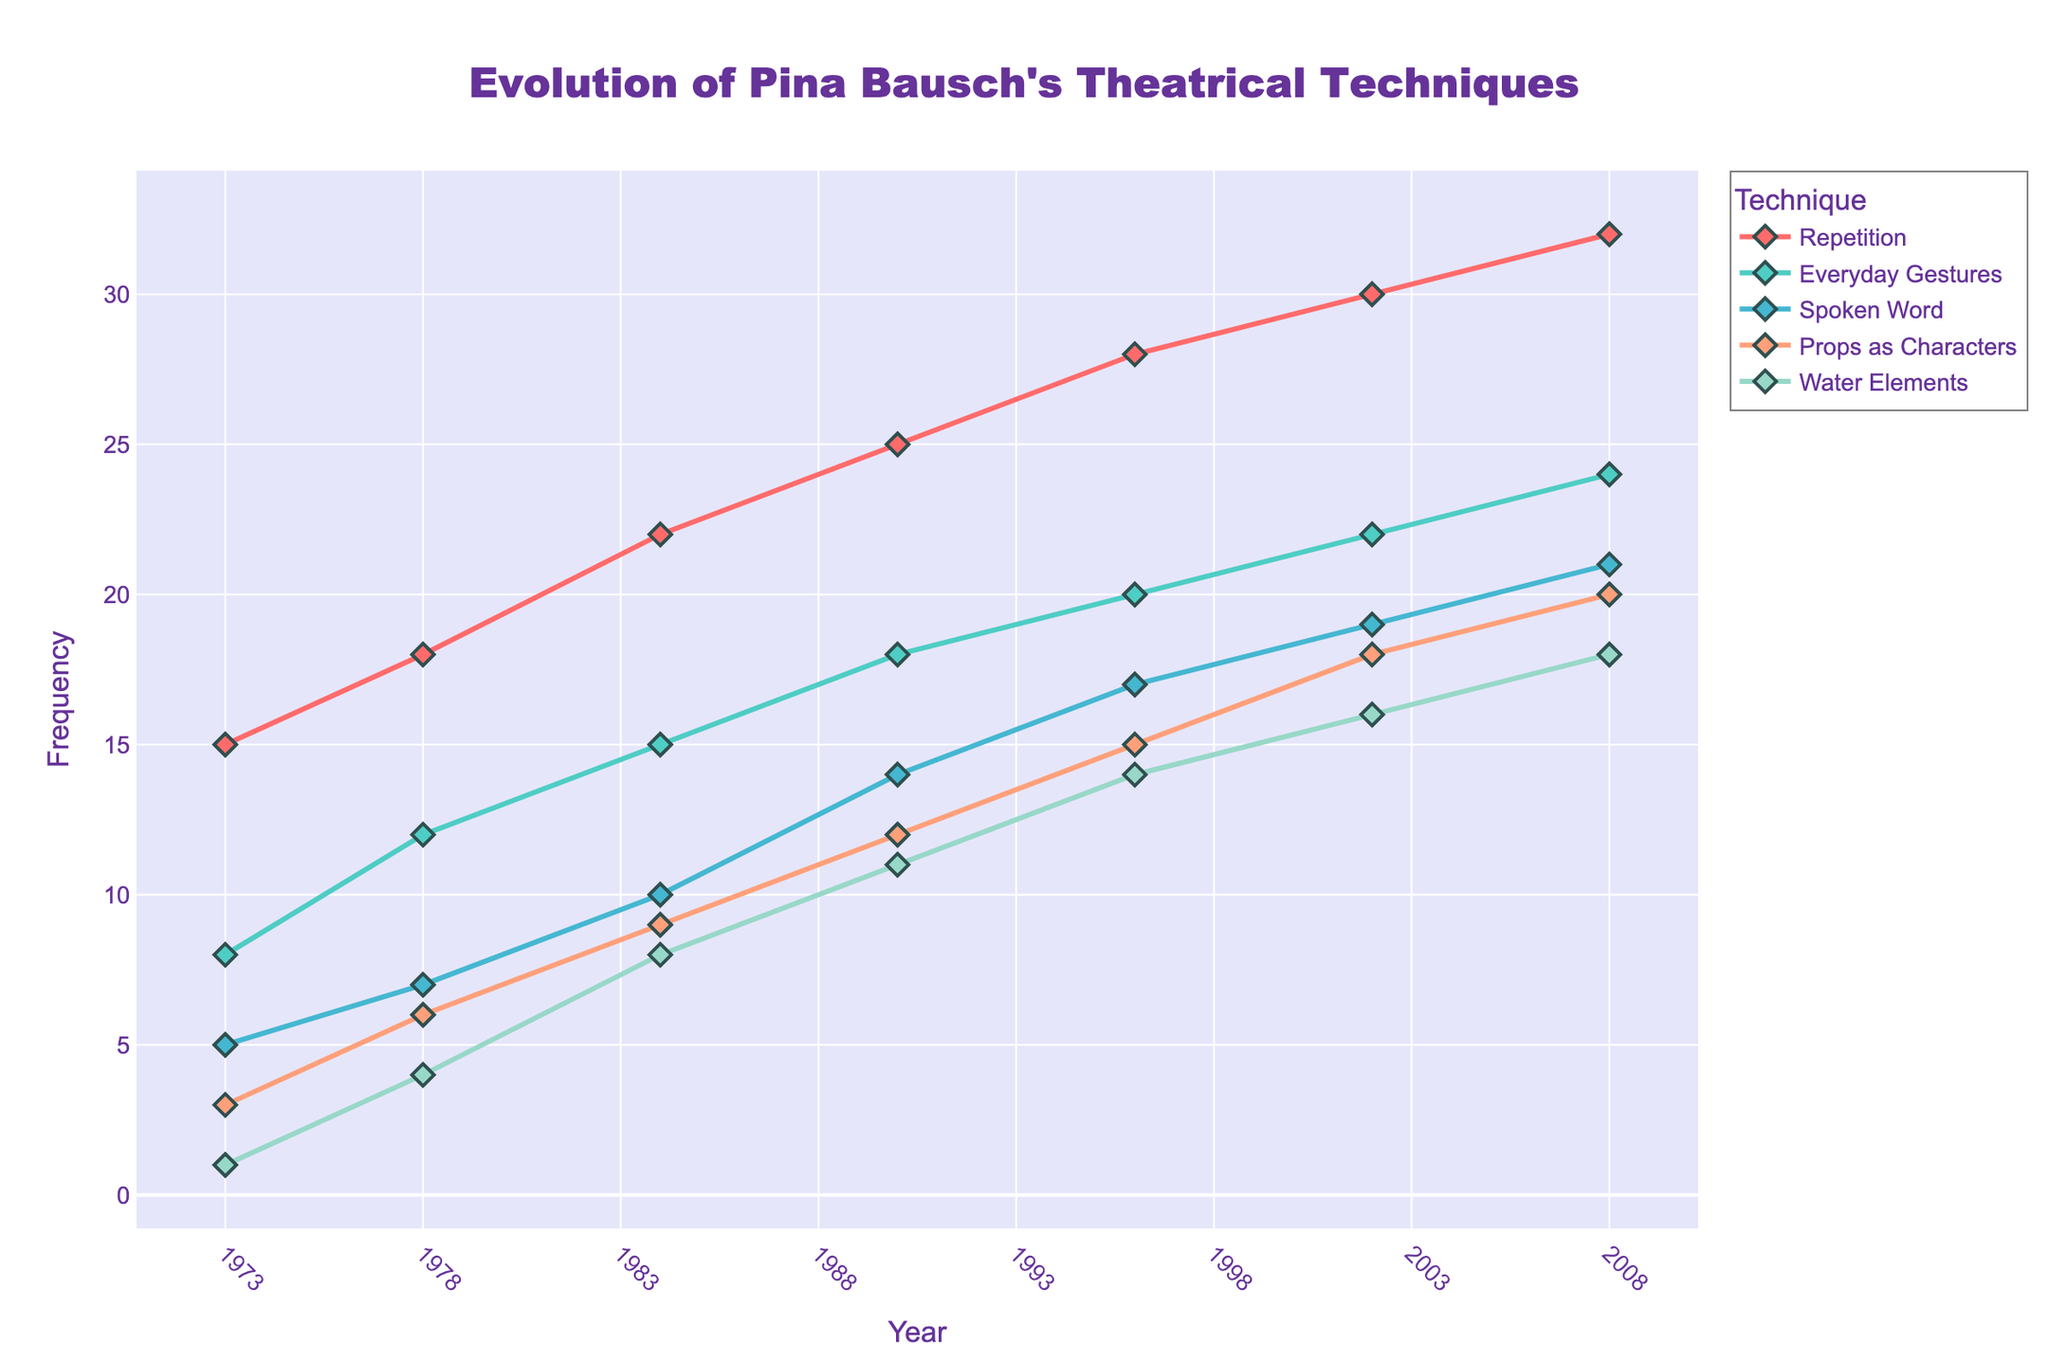What is the title of the figure? The title of the figure is generally found at the top. In this figure, it states "Evolution of Pina Bausch's Theatrical Techniques".
Answer: Evolution of Pina Bausch's Theatrical Techniques Between 1973 and 2008, which technique shows the highest increase in frequency? To find this, identify the technique with the steepest upward trend by comparing the frequencies in 1973 and 2008, then subtract the 1973 frequency from the 2008 frequency for each technique. The technique "Repetition" goes from 15 in 1973 to 32 in 2008, which is an increase of 17, the largest rise.
Answer: Repetition Which technique had the lowest frequency in 1973? Look for the data points in 1973 and identify the one with the smallest y-value. For 1973, the frequencies are: Repetition (15), Everyday Gestures (8), Spoken Word (5), Props as Characters (3), and Water Elements (1). "Water Elements" has the lowest frequency.
Answer: Water Elements During which year did the usage of "Props as Characters" surpass 10 for the first time? Check the frequency trend of "Props as Characters" over the years. The frequency is less than 10 until 1990, where it first becomes 12.
Answer: 1990 What is the average frequency of "Spoken Word" across all the years? Calculate the sum of the frequencies of "Spoken Word" for all the years provided and then divide by the number of years. (5 + 7 + 10 + 14 + 17 + 19 + 21) / 7 = 93 / 7 = 13.29
Answer: 13.29 What is the median frequency of the "Water Elements" technique over the years? List the frequencies of "Water Elements" in ascending order (1, 4, 8, 11, 14, 16, 18). The median is the middle value: 11.
Answer: 11 Which technique had the greatest frequency in the year 2002? Look at the frequencies in 2002: Repetition (30), Everyday Gestures (22), Spoken Word (19), Props as Characters (18), Water Elements (16). "Repetition" has the highest frequency.
Answer: Repetition How many years show a frequency greater than 10 for the "Everyday Gestures" technique? Check each year for "Everyday Gestures" and count instances where the frequency exceeds 10: 1973 (8), 1978 (12), 1984 (15), 1990 (18), 1996 (20), 2002 (22), 2008 (24). Five of these years have frequencies greater than 10.
Answer: 5 What interval did the frequency of "Repetition" surpass 25 for the first time? Track the frequency of "Repetition" by year. It remained below 25 until it reached 28 in 1996.
Answer: 1996 In what year was the frequency of "Everyday Gestures" half of that of "Repetition"? For this, compare the frequencies of "Everyday Gestures" and "Repetition" by year to find when "Everyday Gestures" is half of "Repetition". In 1990, "Everyday Gestures" is 18, and "Repetition" is 25, which is fairly close, but the exact condition doesn't occur; however, this is a notable close value.
Answer: 1990 